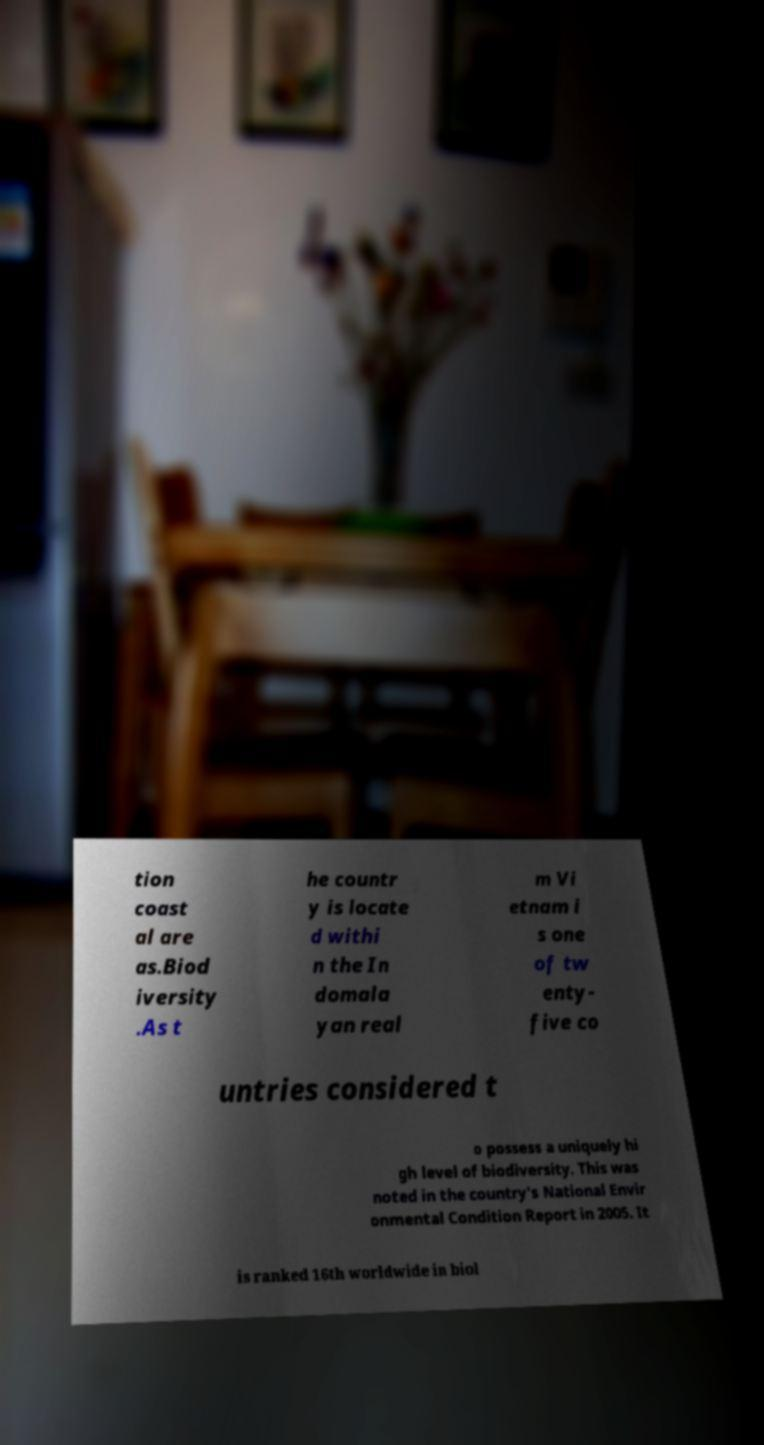I need the written content from this picture converted into text. Can you do that? tion coast al are as.Biod iversity .As t he countr y is locate d withi n the In domala yan real m Vi etnam i s one of tw enty- five co untries considered t o possess a uniquely hi gh level of biodiversity. This was noted in the country's National Envir onmental Condition Report in 2005. It is ranked 16th worldwide in biol 